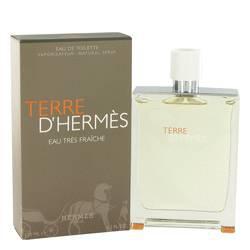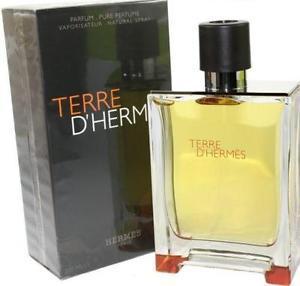The first image is the image on the left, the second image is the image on the right. Given the left and right images, does the statement "The box in each picture is black" hold true? Answer yes or no. Yes. The first image is the image on the left, the second image is the image on the right. Evaluate the accuracy of this statement regarding the images: "All of the perfumes are in a square shaped bottle.". Is it true? Answer yes or no. Yes. 